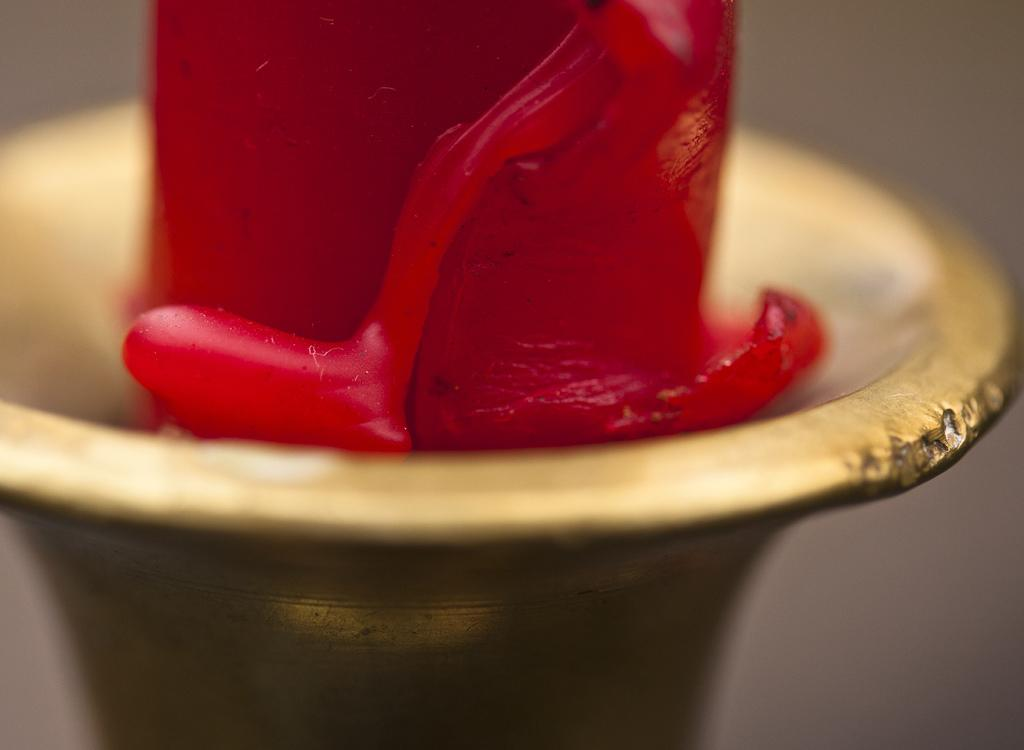What material is present in the image? There is wax in the image. Where is the wax located? The wax is on a stand. How many goldfish are swimming in the wax in the image? There are no goldfish present in the image; it only features wax on a stand. 